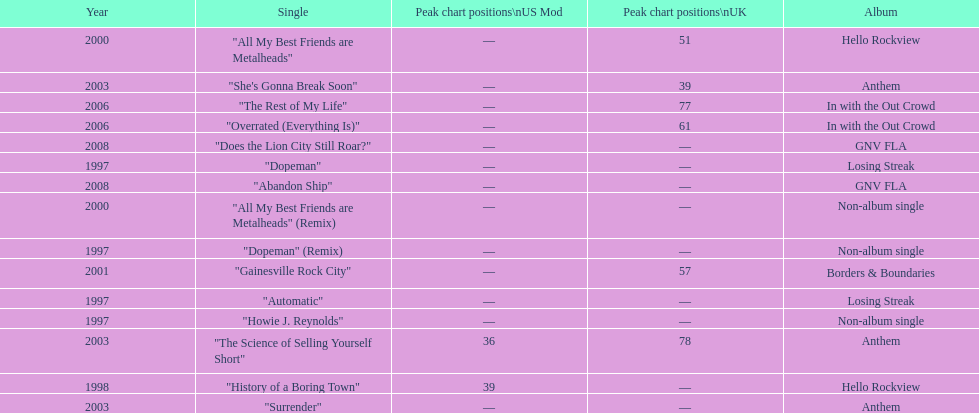Which year has the most singles? 1997. 